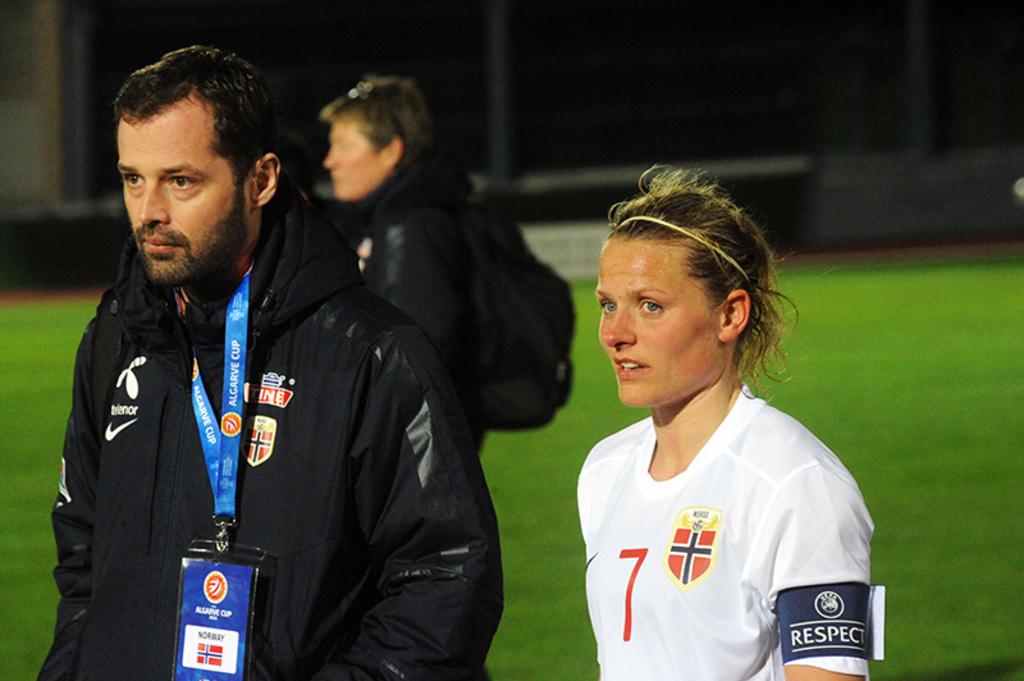Is the card blue on the man on the left?
Provide a short and direct response. Answering does not require reading text in the image. 